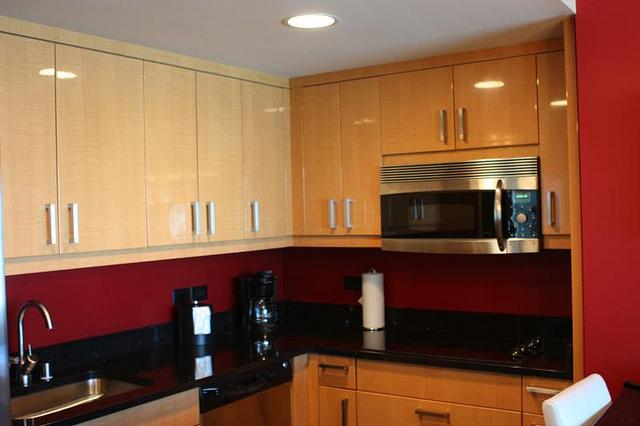What material is the sink made of? metal 